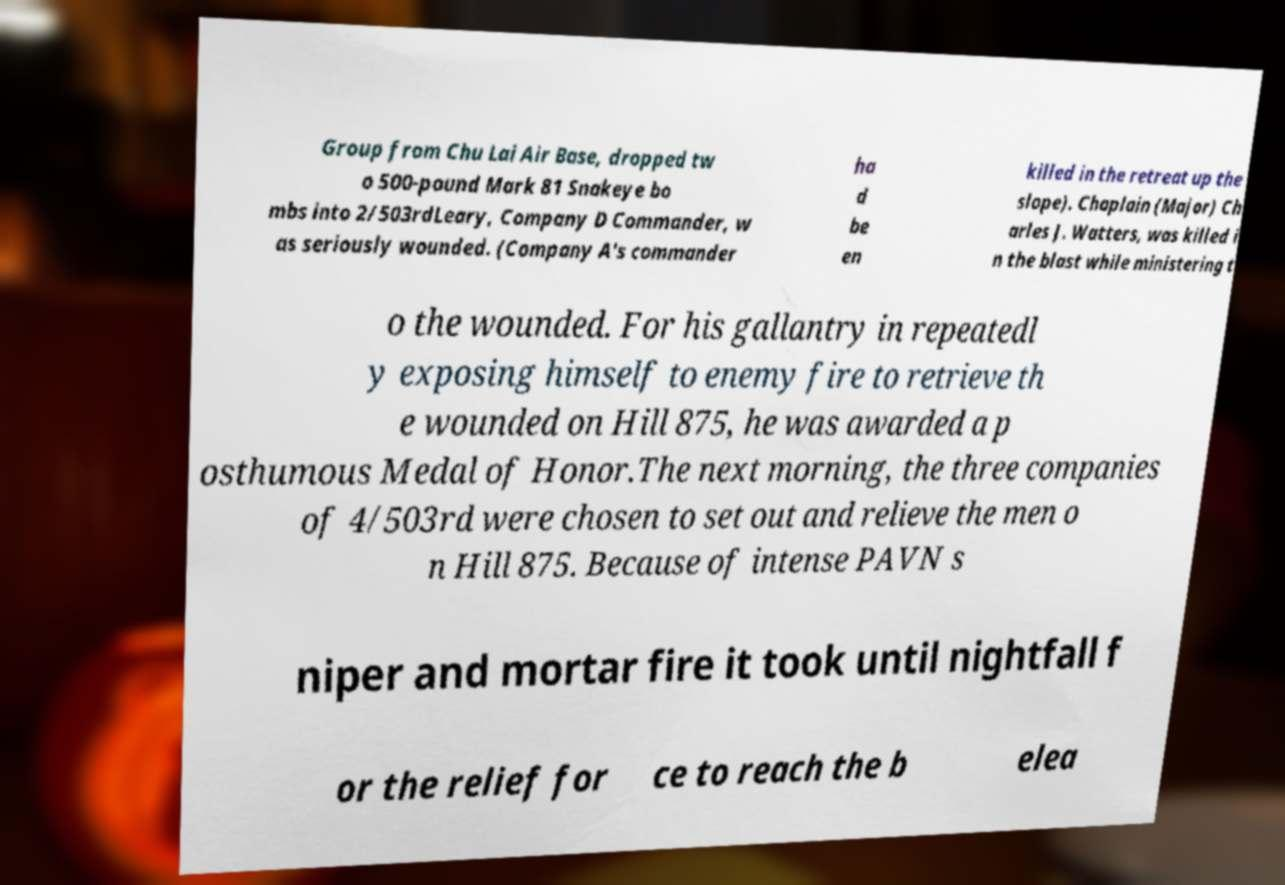Can you read and provide the text displayed in the image?This photo seems to have some interesting text. Can you extract and type it out for me? Group from Chu Lai Air Base, dropped tw o 500-pound Mark 81 Snakeye bo mbs into 2/503rdLeary, Company D Commander, w as seriously wounded. (Company A's commander ha d be en killed in the retreat up the slope). Chaplain (Major) Ch arles J. Watters, was killed i n the blast while ministering t o the wounded. For his gallantry in repeatedl y exposing himself to enemy fire to retrieve th e wounded on Hill 875, he was awarded a p osthumous Medal of Honor.The next morning, the three companies of 4/503rd were chosen to set out and relieve the men o n Hill 875. Because of intense PAVN s niper and mortar fire it took until nightfall f or the relief for ce to reach the b elea 